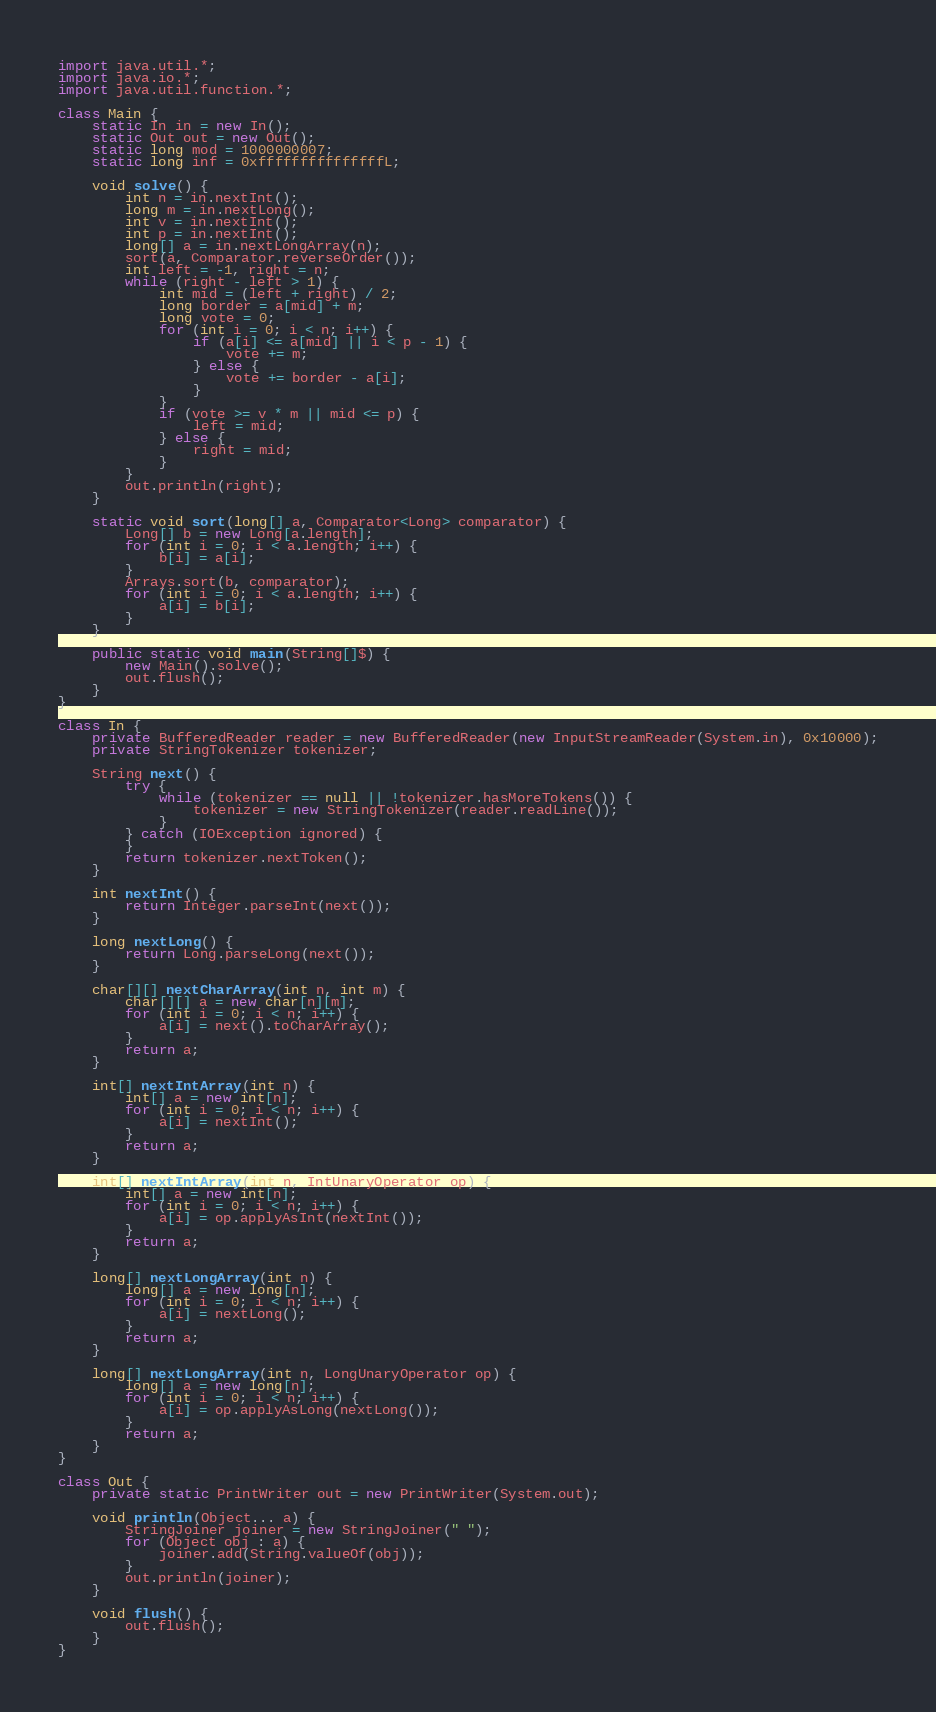<code> <loc_0><loc_0><loc_500><loc_500><_Java_>import java.util.*;
import java.io.*;
import java.util.function.*;

class Main {
    static In in = new In();
    static Out out = new Out();
    static long mod = 1000000007;
    static long inf = 0xfffffffffffffffL;

    void solve() {
        int n = in.nextInt();
        long m = in.nextLong();
        int v = in.nextInt();
        int p = in.nextInt();
        long[] a = in.nextLongArray(n);
        sort(a, Comparator.reverseOrder());
        int left = -1, right = n;
        while (right - left > 1) {
            int mid = (left + right) / 2;
            long border = a[mid] + m;
            long vote = 0;
            for (int i = 0; i < n; i++) {
                if (a[i] <= a[mid] || i < p - 1) {
                    vote += m;
                } else {
                    vote += border - a[i];
                }
            }
            if (vote >= v * m || mid <= p) {
                left = mid;
            } else {
                right = mid;
            }
        }
        out.println(right);
    }

    static void sort(long[] a, Comparator<Long> comparator) {
        Long[] b = new Long[a.length];
        for (int i = 0; i < a.length; i++) {
            b[i] = a[i];
        }
        Arrays.sort(b, comparator);
        for (int i = 0; i < a.length; i++) {
            a[i] = b[i];
        }
    }

    public static void main(String[]$) {
        new Main().solve();
        out.flush();
    }
}

class In {
    private BufferedReader reader = new BufferedReader(new InputStreamReader(System.in), 0x10000);
    private StringTokenizer tokenizer;

    String next() {
        try {
            while (tokenizer == null || !tokenizer.hasMoreTokens()) {
                tokenizer = new StringTokenizer(reader.readLine());
            }
        } catch (IOException ignored) {
        }
        return tokenizer.nextToken();
    }

    int nextInt() {
        return Integer.parseInt(next());
    }

    long nextLong() {
        return Long.parseLong(next());
    }

    char[][] nextCharArray(int n, int m) {
        char[][] a = new char[n][m];
        for (int i = 0; i < n; i++) {
            a[i] = next().toCharArray();
        }
        return a;
    }

    int[] nextIntArray(int n) {
        int[] a = new int[n];
        for (int i = 0; i < n; i++) {
            a[i] = nextInt();
        }
        return a;
    }

    int[] nextIntArray(int n, IntUnaryOperator op) {
        int[] a = new int[n];
        for (int i = 0; i < n; i++) {
            a[i] = op.applyAsInt(nextInt());
        }
        return a;
    }

    long[] nextLongArray(int n) {
        long[] a = new long[n];
        for (int i = 0; i < n; i++) {
            a[i] = nextLong();
        }
        return a;
    }

    long[] nextLongArray(int n, LongUnaryOperator op) {
        long[] a = new long[n];
        for (int i = 0; i < n; i++) {
            a[i] = op.applyAsLong(nextLong());
        }
        return a;
    }
}

class Out {
    private static PrintWriter out = new PrintWriter(System.out);

    void println(Object... a) {
        StringJoiner joiner = new StringJoiner(" ");
        for (Object obj : a) {
            joiner.add(String.valueOf(obj));
        }
        out.println(joiner);
    }

    void flush() {
        out.flush();
    }
}
</code> 